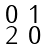Convert formula to latex. <formula><loc_0><loc_0><loc_500><loc_500>\begin{smallmatrix} 0 & 1 \\ 2 & 0 \end{smallmatrix}</formula> 